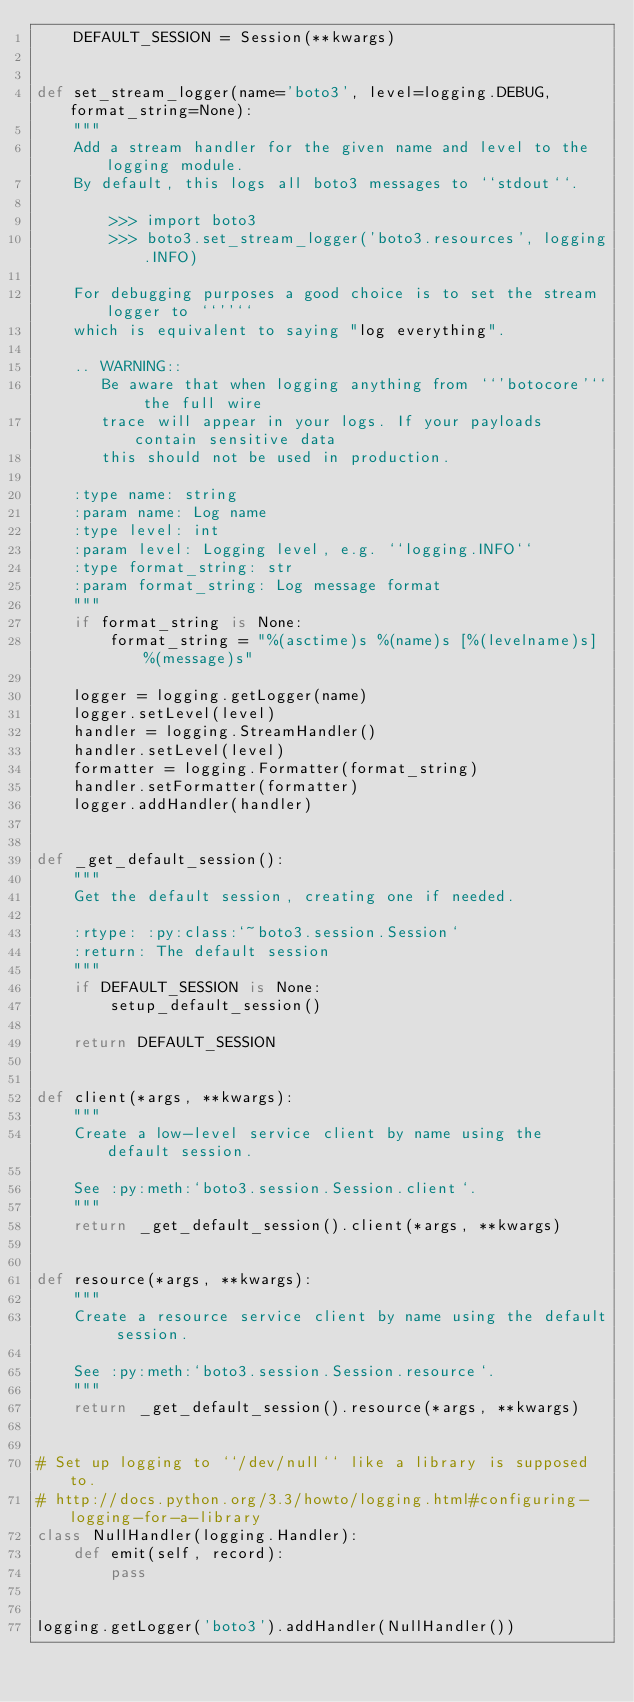Convert code to text. <code><loc_0><loc_0><loc_500><loc_500><_Python_>    DEFAULT_SESSION = Session(**kwargs)


def set_stream_logger(name='boto3', level=logging.DEBUG, format_string=None):
    """
    Add a stream handler for the given name and level to the logging module.
    By default, this logs all boto3 messages to ``stdout``.

        >>> import boto3
        >>> boto3.set_stream_logger('boto3.resources', logging.INFO)

    For debugging purposes a good choice is to set the stream logger to ``''``
    which is equivalent to saying "log everything".

    .. WARNING::
       Be aware that when logging anything from ``'botocore'`` the full wire
       trace will appear in your logs. If your payloads contain sensitive data
       this should not be used in production.

    :type name: string
    :param name: Log name
    :type level: int
    :param level: Logging level, e.g. ``logging.INFO``
    :type format_string: str
    :param format_string: Log message format
    """
    if format_string is None:
        format_string = "%(asctime)s %(name)s [%(levelname)s] %(message)s"

    logger = logging.getLogger(name)
    logger.setLevel(level)
    handler = logging.StreamHandler()
    handler.setLevel(level)
    formatter = logging.Formatter(format_string)
    handler.setFormatter(formatter)
    logger.addHandler(handler)


def _get_default_session():
    """
    Get the default session, creating one if needed.

    :rtype: :py:class:`~boto3.session.Session`
    :return: The default session
    """
    if DEFAULT_SESSION is None:
        setup_default_session()

    return DEFAULT_SESSION


def client(*args, **kwargs):
    """
    Create a low-level service client by name using the default session.

    See :py:meth:`boto3.session.Session.client`.
    """
    return _get_default_session().client(*args, **kwargs)


def resource(*args, **kwargs):
    """
    Create a resource service client by name using the default session.

    See :py:meth:`boto3.session.Session.resource`.
    """
    return _get_default_session().resource(*args, **kwargs)


# Set up logging to ``/dev/null`` like a library is supposed to.
# http://docs.python.org/3.3/howto/logging.html#configuring-logging-for-a-library
class NullHandler(logging.Handler):
    def emit(self, record):
        pass


logging.getLogger('boto3').addHandler(NullHandler())
</code> 